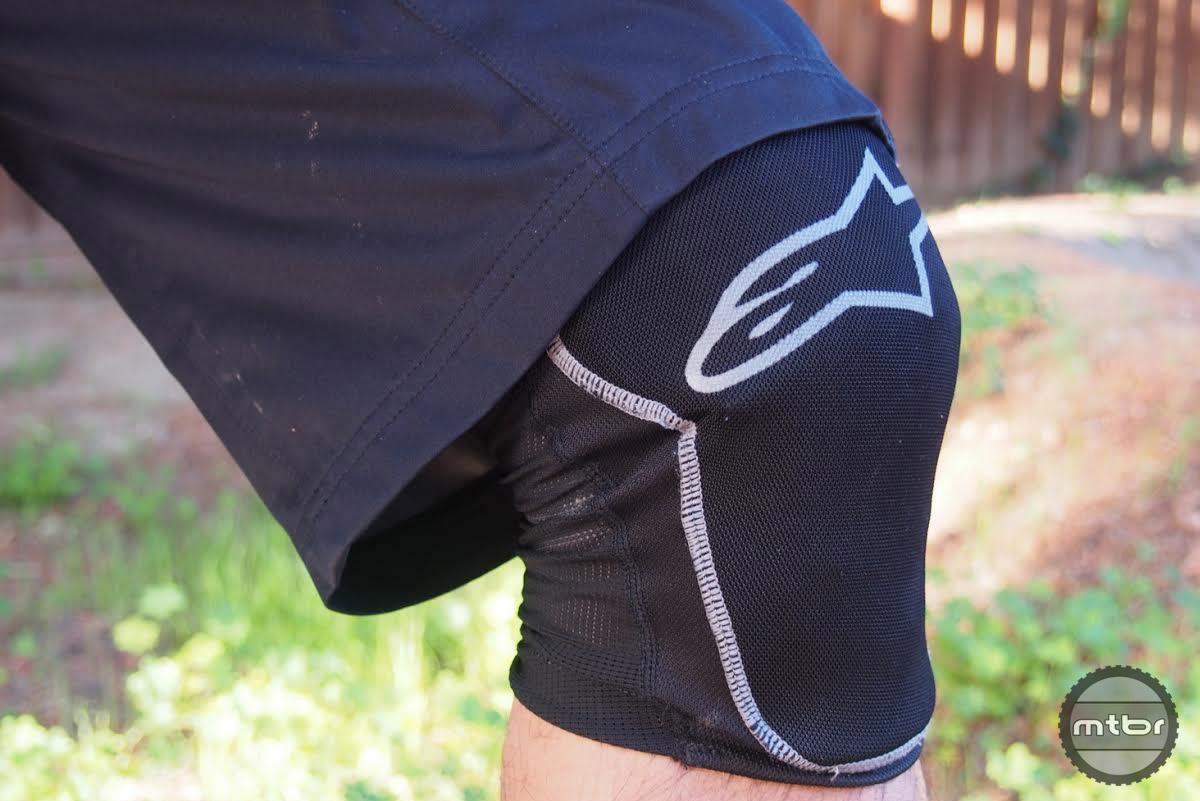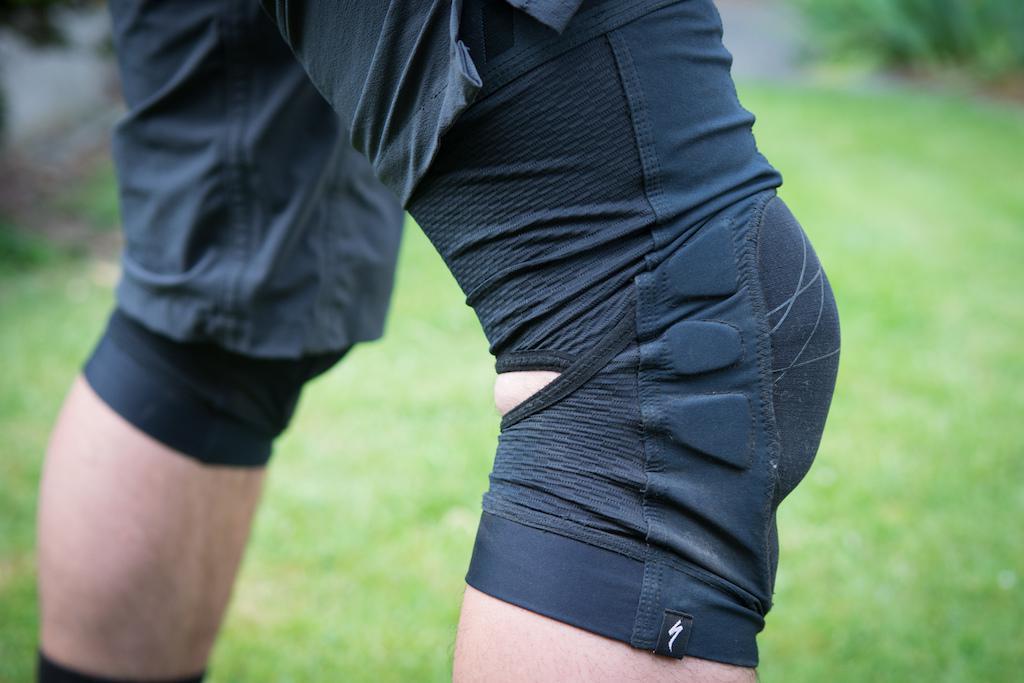The first image is the image on the left, the second image is the image on the right. For the images shown, is this caption "One of the knees in the image on the left is bent greater than ninety degrees." true? Answer yes or no. No. 